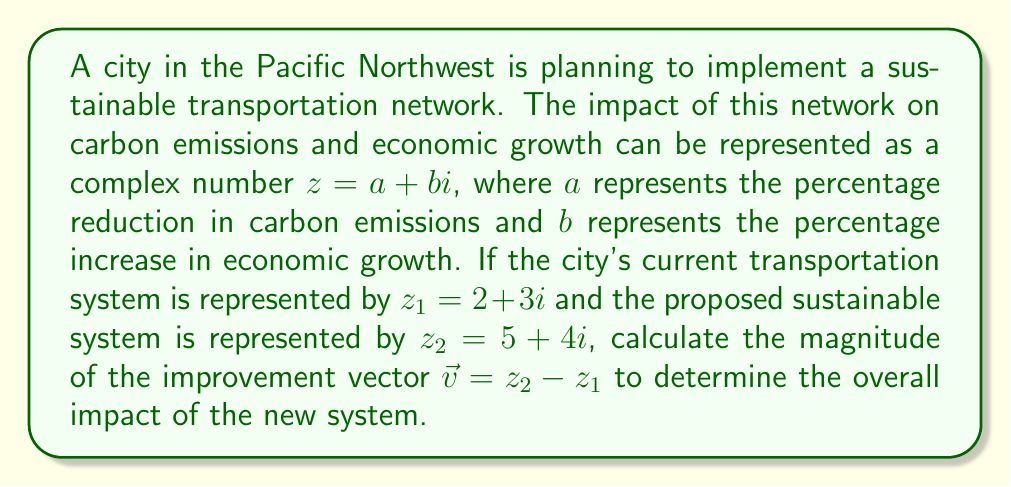Solve this math problem. To solve this problem, we'll follow these steps:

1. Calculate the improvement vector $\vec{v}$:
   $\vec{v} = z_2 - z_1 = (5 + 4i) - (2 + 3i) = (5 - 2) + (4 - 3)i = 3 + i$

2. The magnitude of a complex number $z = a + bi$ is given by the formula:
   $|z| = \sqrt{a^2 + b^2}$

3. For our improvement vector $\vec{v} = 3 + i$:
   $|\vec{v}| = \sqrt{3^2 + 1^2}$

4. Simplify:
   $|\vec{v}| = \sqrt{9 + 1} = \sqrt{10}$

5. The final result can be left as $\sqrt{10}$ or approximated to a decimal:
   $|\vec{v}| \approx 3.16$

This magnitude represents the overall impact of the new sustainable transportation system, combining both the reduction in carbon emissions and the increase in economic growth.
Answer: $\sqrt{10}$ or approximately 3.16 